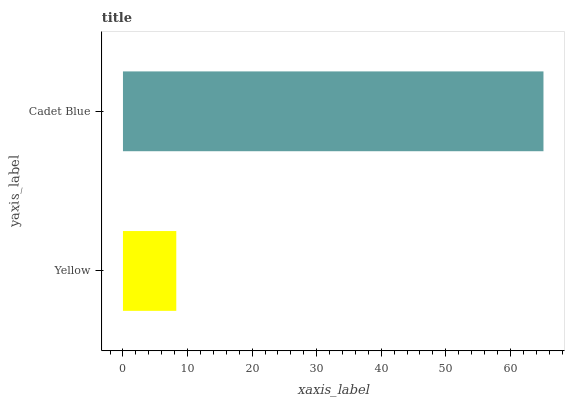Is Yellow the minimum?
Answer yes or no. Yes. Is Cadet Blue the maximum?
Answer yes or no. Yes. Is Cadet Blue the minimum?
Answer yes or no. No. Is Cadet Blue greater than Yellow?
Answer yes or no. Yes. Is Yellow less than Cadet Blue?
Answer yes or no. Yes. Is Yellow greater than Cadet Blue?
Answer yes or no. No. Is Cadet Blue less than Yellow?
Answer yes or no. No. Is Cadet Blue the high median?
Answer yes or no. Yes. Is Yellow the low median?
Answer yes or no. Yes. Is Yellow the high median?
Answer yes or no. No. Is Cadet Blue the low median?
Answer yes or no. No. 